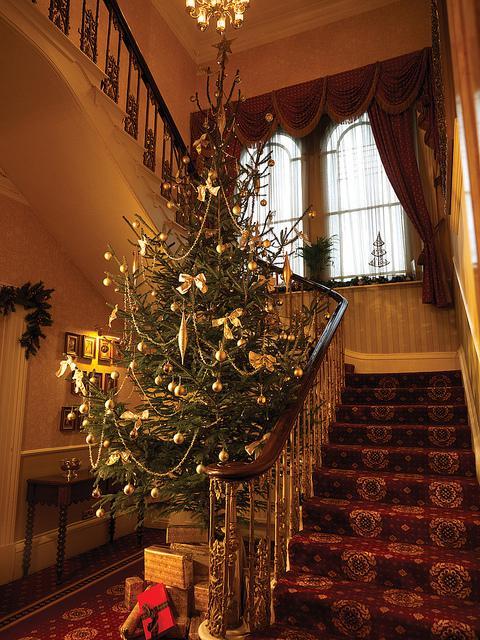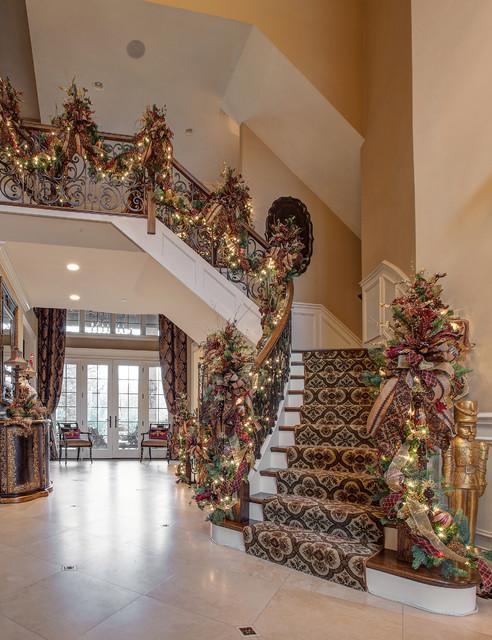The first image is the image on the left, the second image is the image on the right. Considering the images on both sides, is "One image shows a staircase with white bars and a brown handrail that descends diagnonally to the right and has an evergreen tree beside it." valid? Answer yes or no. No. The first image is the image on the left, the second image is the image on the right. Assess this claim about the two images: "There are no visible windows within any of these rooms.". Correct or not? Answer yes or no. No. 